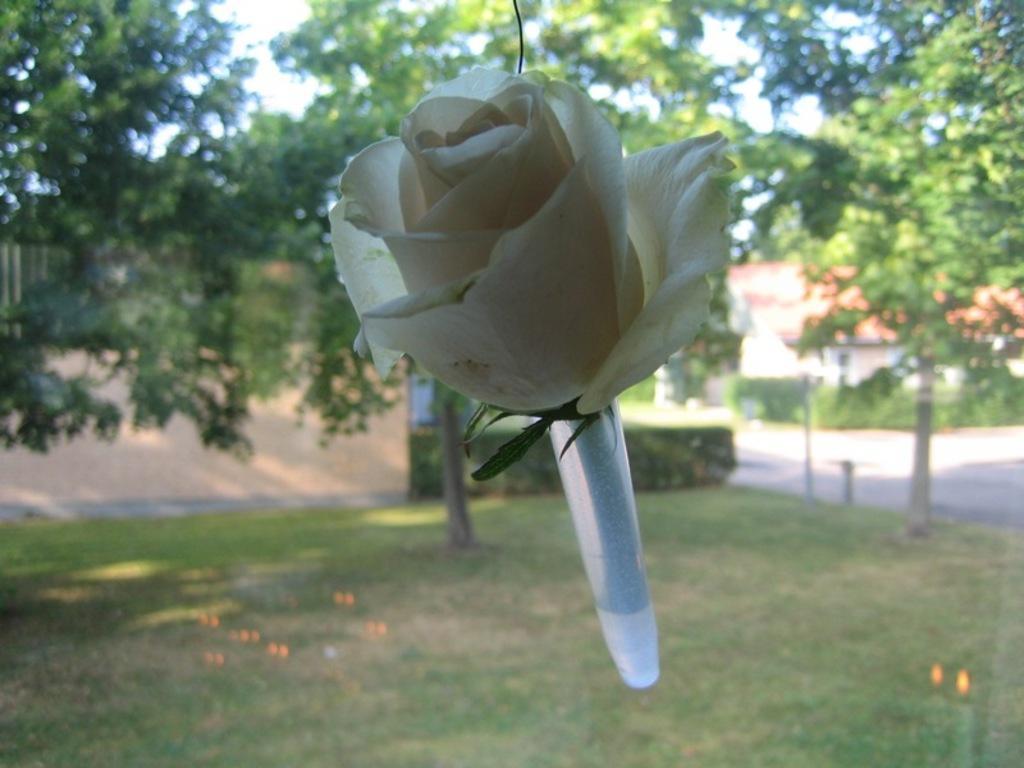How would you summarize this image in a sentence or two? We can see white flower. In the background we can see trees,house and grass. 